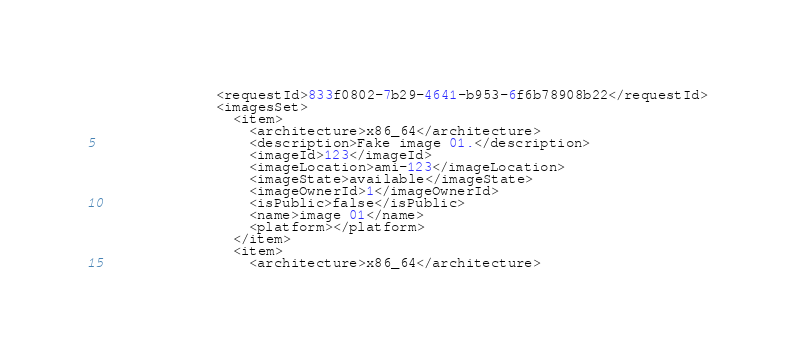<code> <loc_0><loc_0><loc_500><loc_500><_Python_>              <requestId>833f0802-7b29-4641-b953-6f6b78908b22</requestId>
              <imagesSet>
                <item>
                  <architecture>x86_64</architecture>
                  <description>Fake image 01.</description>
                  <imageId>123</imageId>
                  <imageLocation>ami-123</imageLocation>
                  <imageState>available</imageState>
                  <imageOwnerId>1</imageOwnerId>
                  <isPublic>false</isPublic>
                  <name>image 01</name>
                  <platform></platform>
                </item>
                <item>
                  <architecture>x86_64</architecture></code> 